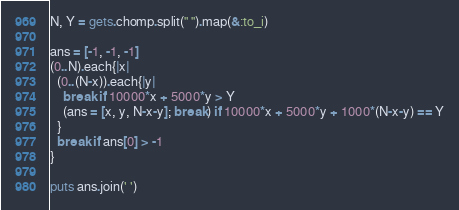Convert code to text. <code><loc_0><loc_0><loc_500><loc_500><_Ruby_>N, Y = gets.chomp.split(" ").map(&:to_i)

ans = [-1, -1, -1]
(0..N).each{|x|
  (0..(N-x)).each{|y|
    break if 10000*x + 5000*y > Y
    (ans = [x, y, N-x-y]; break) if 10000*x + 5000*y + 1000*(N-x-y) == Y
  }
  break if ans[0] > -1
}

puts ans.join(' ')
</code> 